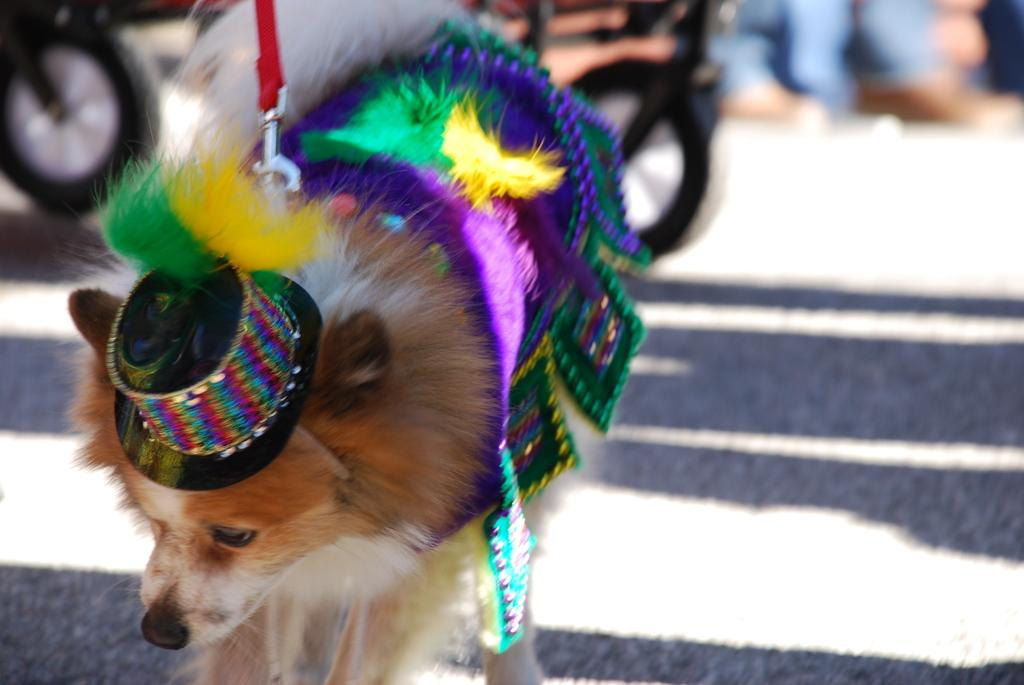What type of animal is in the image? There is a dog in the image. What is the dog wearing? The dog is wearing a hat. Can you describe the background of the image? The background of the image is blurred. How many wheels can be seen in the image? There are two wheels in the image, one in the top left corner and another at the top. What does the dog say with its mouth in the image? The image does not show the dog's mouth or any sounds it might be making, so we cannot determine what it is saying. 